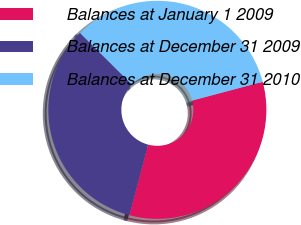Convert chart to OTSL. <chart><loc_0><loc_0><loc_500><loc_500><pie_chart><fcel>Balances at January 1 2009<fcel>Balances at December 31 2009<fcel>Balances at December 31 2010<nl><fcel>33.26%<fcel>33.33%<fcel>33.41%<nl></chart> 